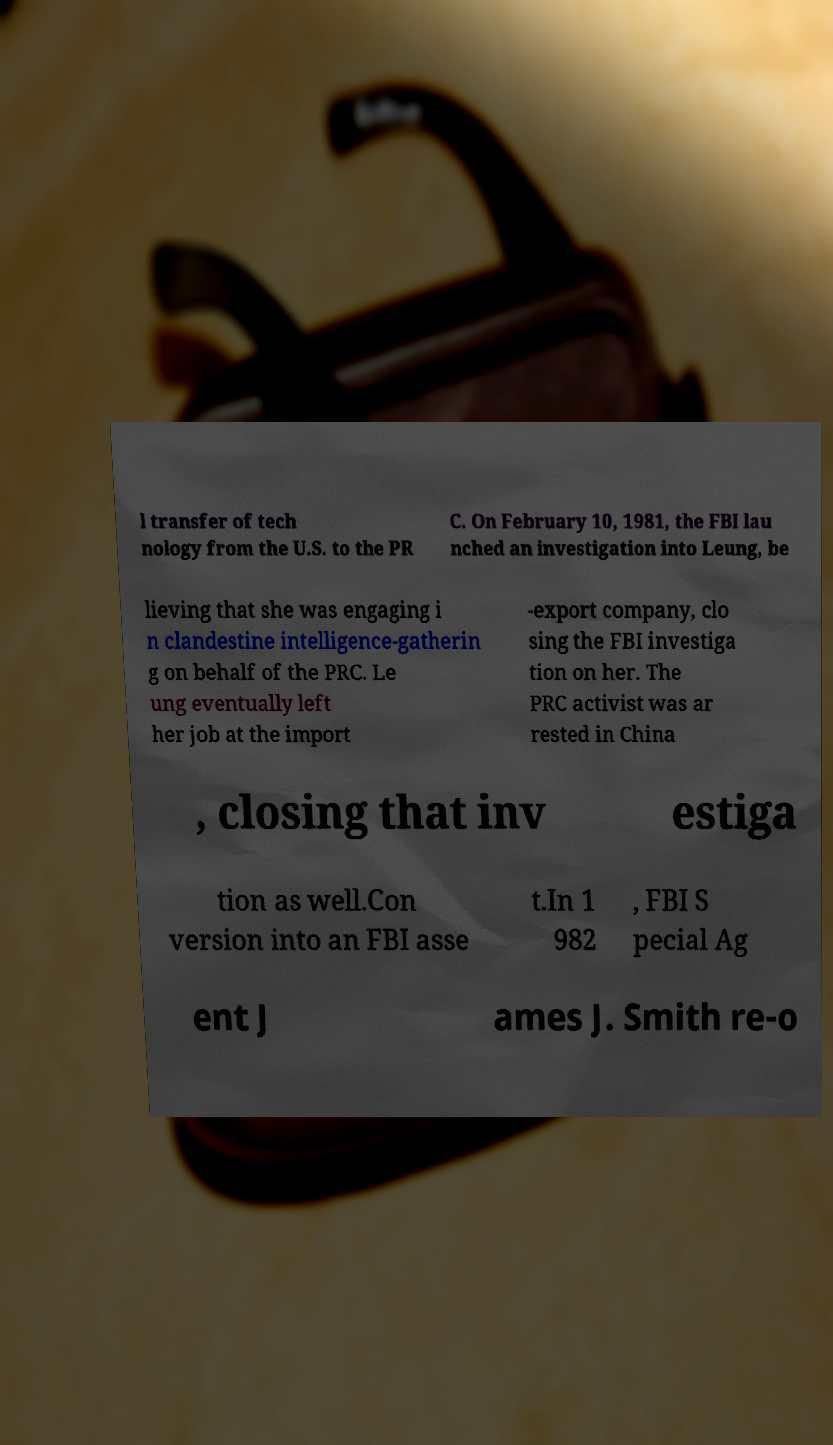What messages or text are displayed in this image? I need them in a readable, typed format. l transfer of tech nology from the U.S. to the PR C. On February 10, 1981, the FBI lau nched an investigation into Leung, be lieving that she was engaging i n clandestine intelligence-gatherin g on behalf of the PRC. Le ung eventually left her job at the import -export company, clo sing the FBI investiga tion on her. The PRC activist was ar rested in China , closing that inv estiga tion as well.Con version into an FBI asse t.In 1 982 , FBI S pecial Ag ent J ames J. Smith re-o 